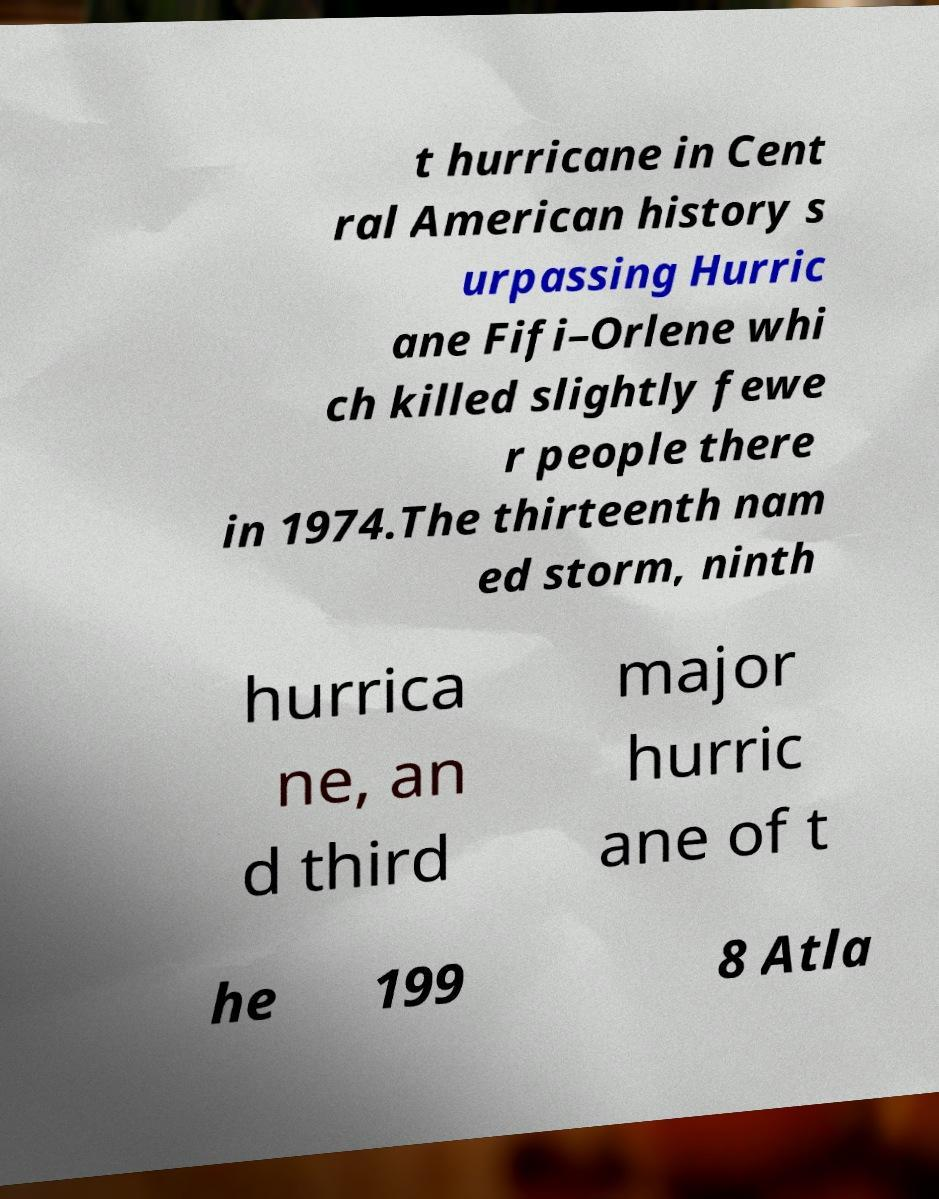I need the written content from this picture converted into text. Can you do that? t hurricane in Cent ral American history s urpassing Hurric ane Fifi–Orlene whi ch killed slightly fewe r people there in 1974.The thirteenth nam ed storm, ninth hurrica ne, an d third major hurric ane of t he 199 8 Atla 